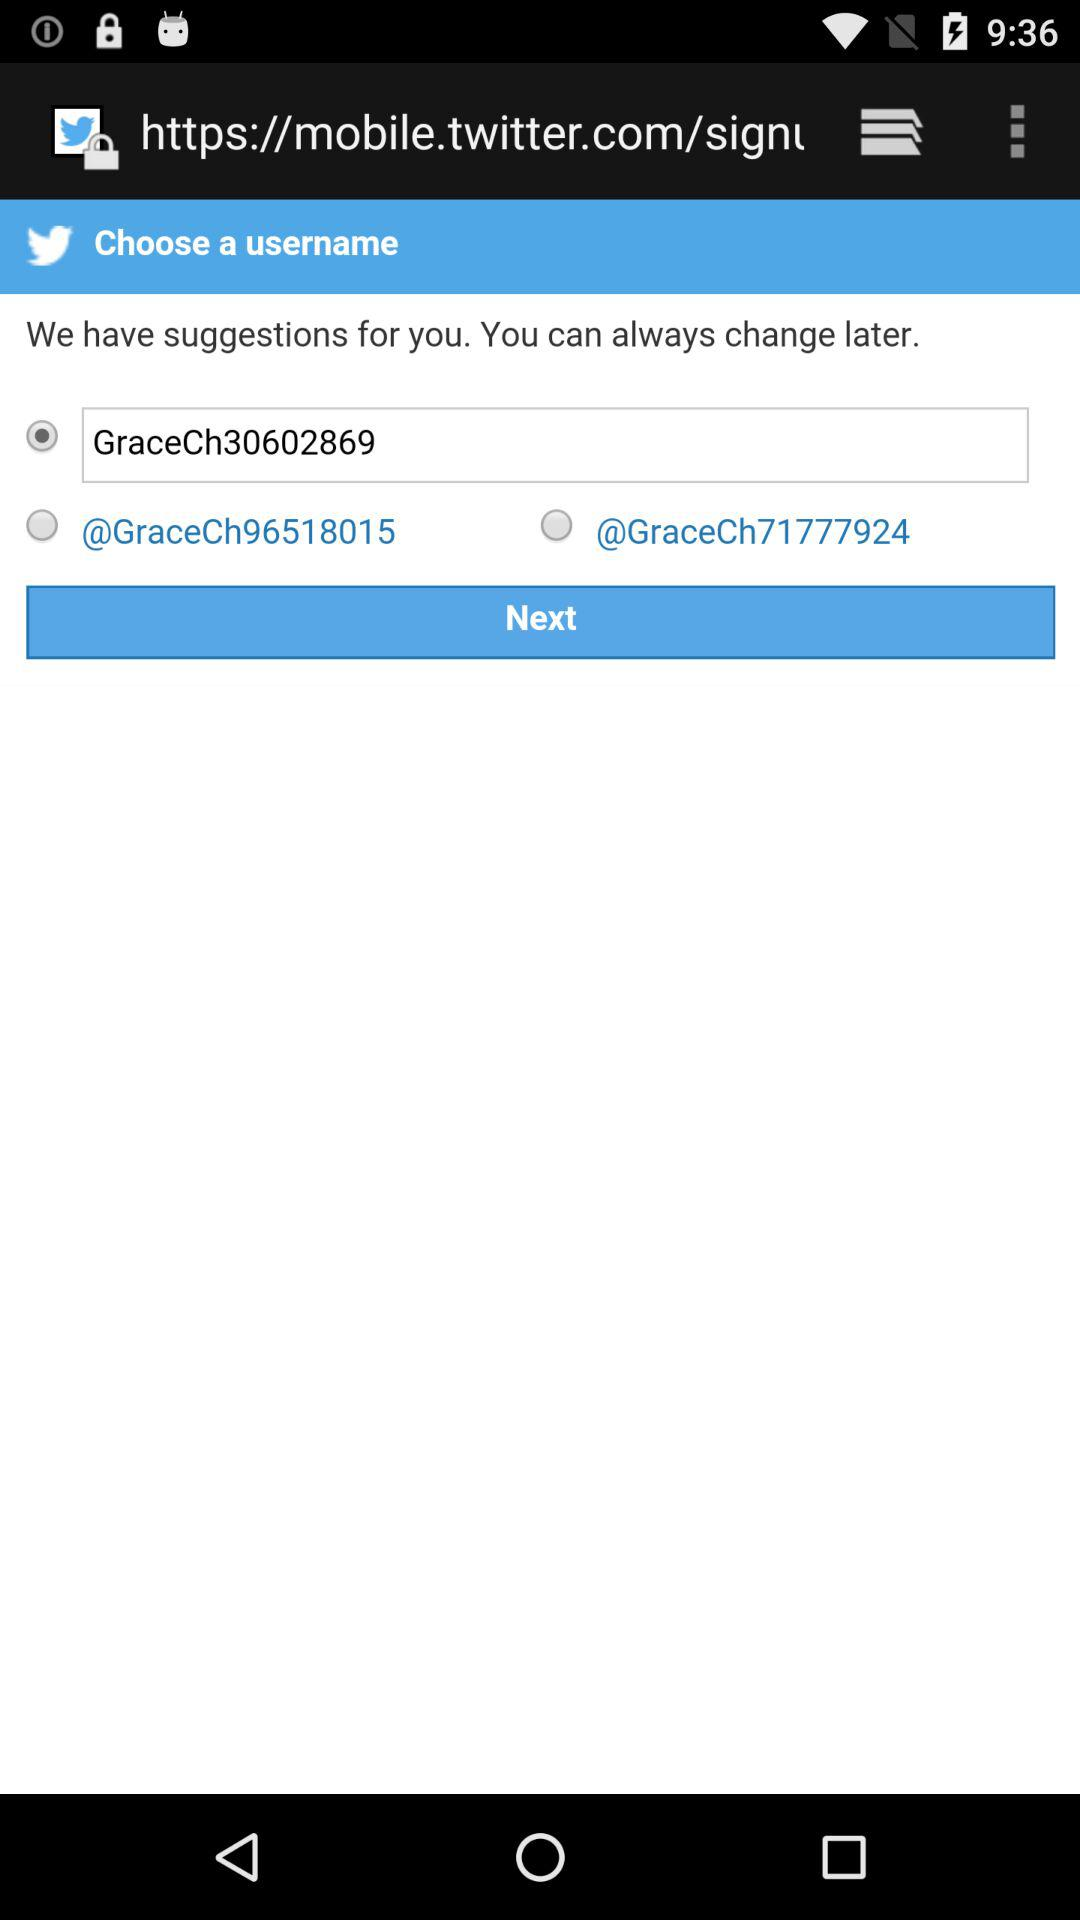How many username suggestions are there?
Answer the question using a single word or phrase. 3 